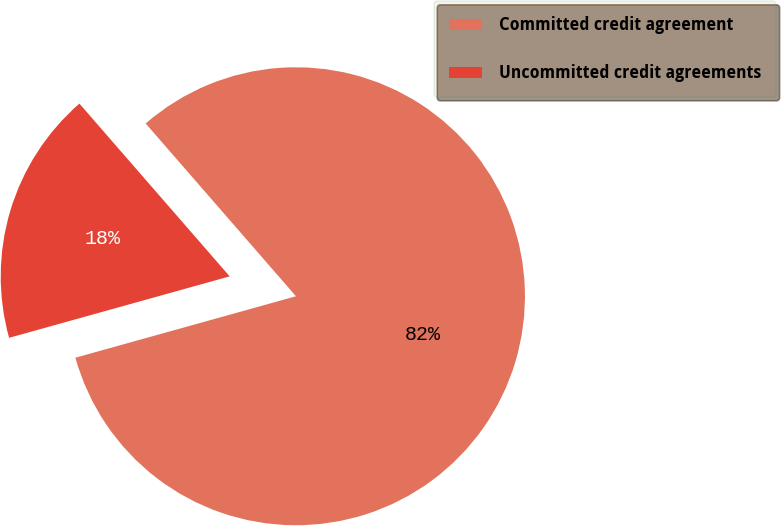<chart> <loc_0><loc_0><loc_500><loc_500><pie_chart><fcel>Committed credit agreement<fcel>Uncommitted credit agreements<nl><fcel>82.07%<fcel>17.93%<nl></chart> 